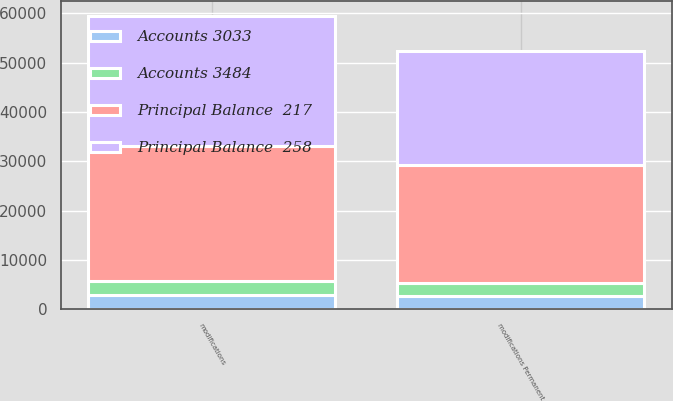<chart> <loc_0><loc_0><loc_500><loc_500><stacked_bar_chart><ecel><fcel>modifications Permanent<fcel>modifications<nl><fcel>Principal Balance  258<fcel>23270<fcel>26303<nl><fcel>Accounts 3484<fcel>2581<fcel>2798<nl><fcel>Principal Balance  217<fcel>23904<fcel>27388<nl><fcel>Accounts 3033<fcel>2693<fcel>2951<nl></chart> 